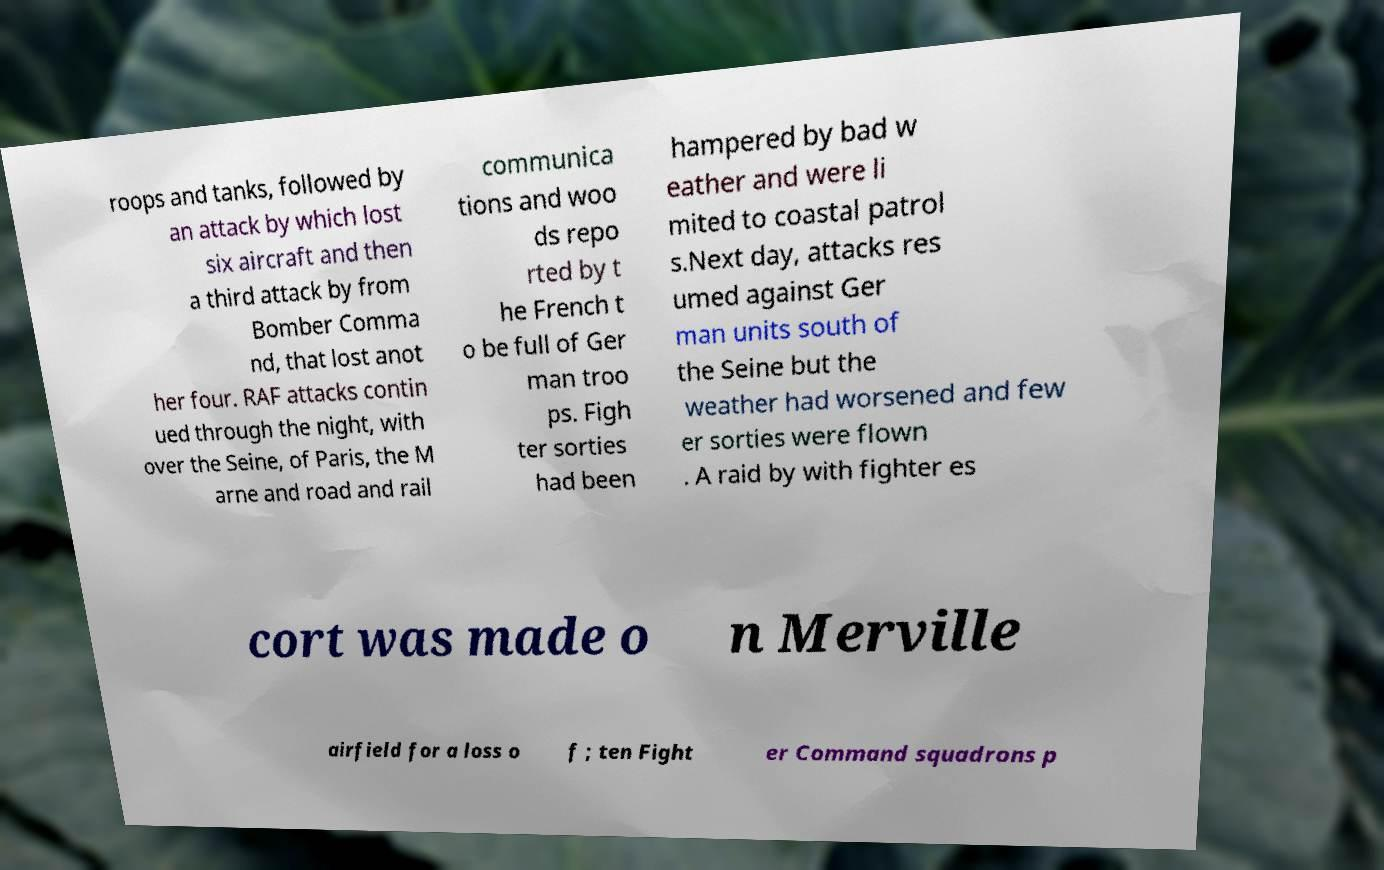Please identify and transcribe the text found in this image. roops and tanks, followed by an attack by which lost six aircraft and then a third attack by from Bomber Comma nd, that lost anot her four. RAF attacks contin ued through the night, with over the Seine, of Paris, the M arne and road and rail communica tions and woo ds repo rted by t he French t o be full of Ger man troo ps. Figh ter sorties had been hampered by bad w eather and were li mited to coastal patrol s.Next day, attacks res umed against Ger man units south of the Seine but the weather had worsened and few er sorties were flown . A raid by with fighter es cort was made o n Merville airfield for a loss o f ; ten Fight er Command squadrons p 